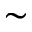<formula> <loc_0><loc_0><loc_500><loc_500>\sim</formula> 